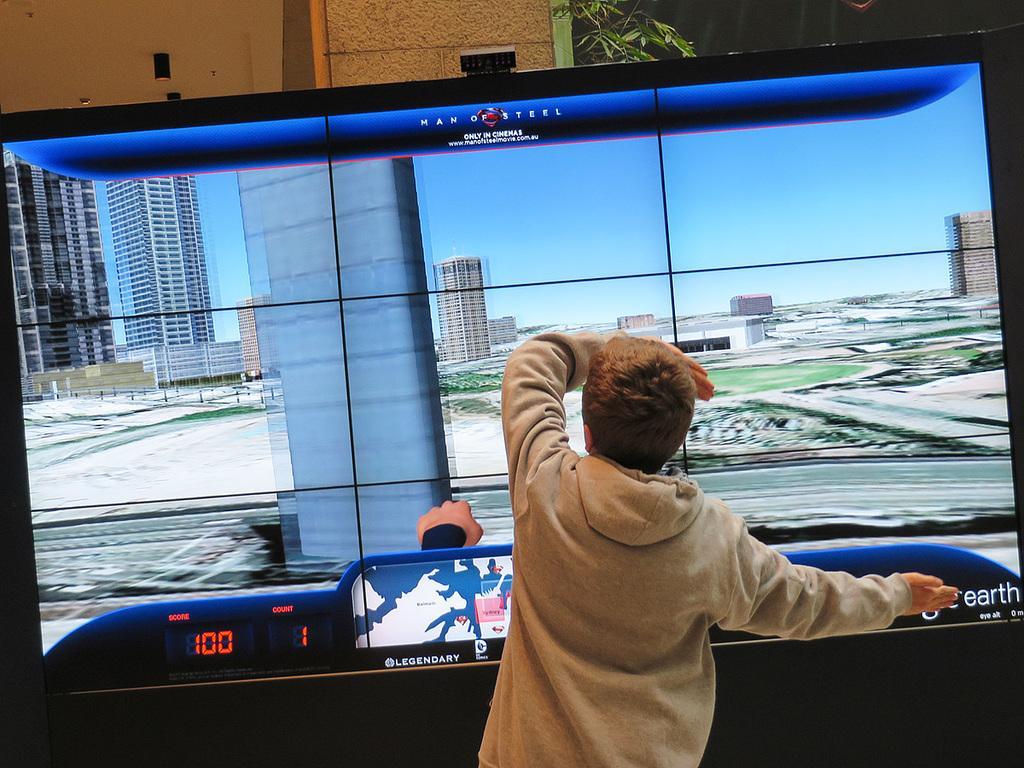How would you summarize this image in a sentence or two? In the picture we can see a boy standing near the video game screen and he is touching the screen and behind the screen we can see a part of the pillar and small plant near it. 